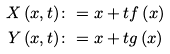<formula> <loc_0><loc_0><loc_500><loc_500>X \left ( x , t \right ) & \colon = x + t f \left ( x \right ) \\ Y \left ( x , t \right ) & \colon = x + t g \left ( x \right )</formula> 